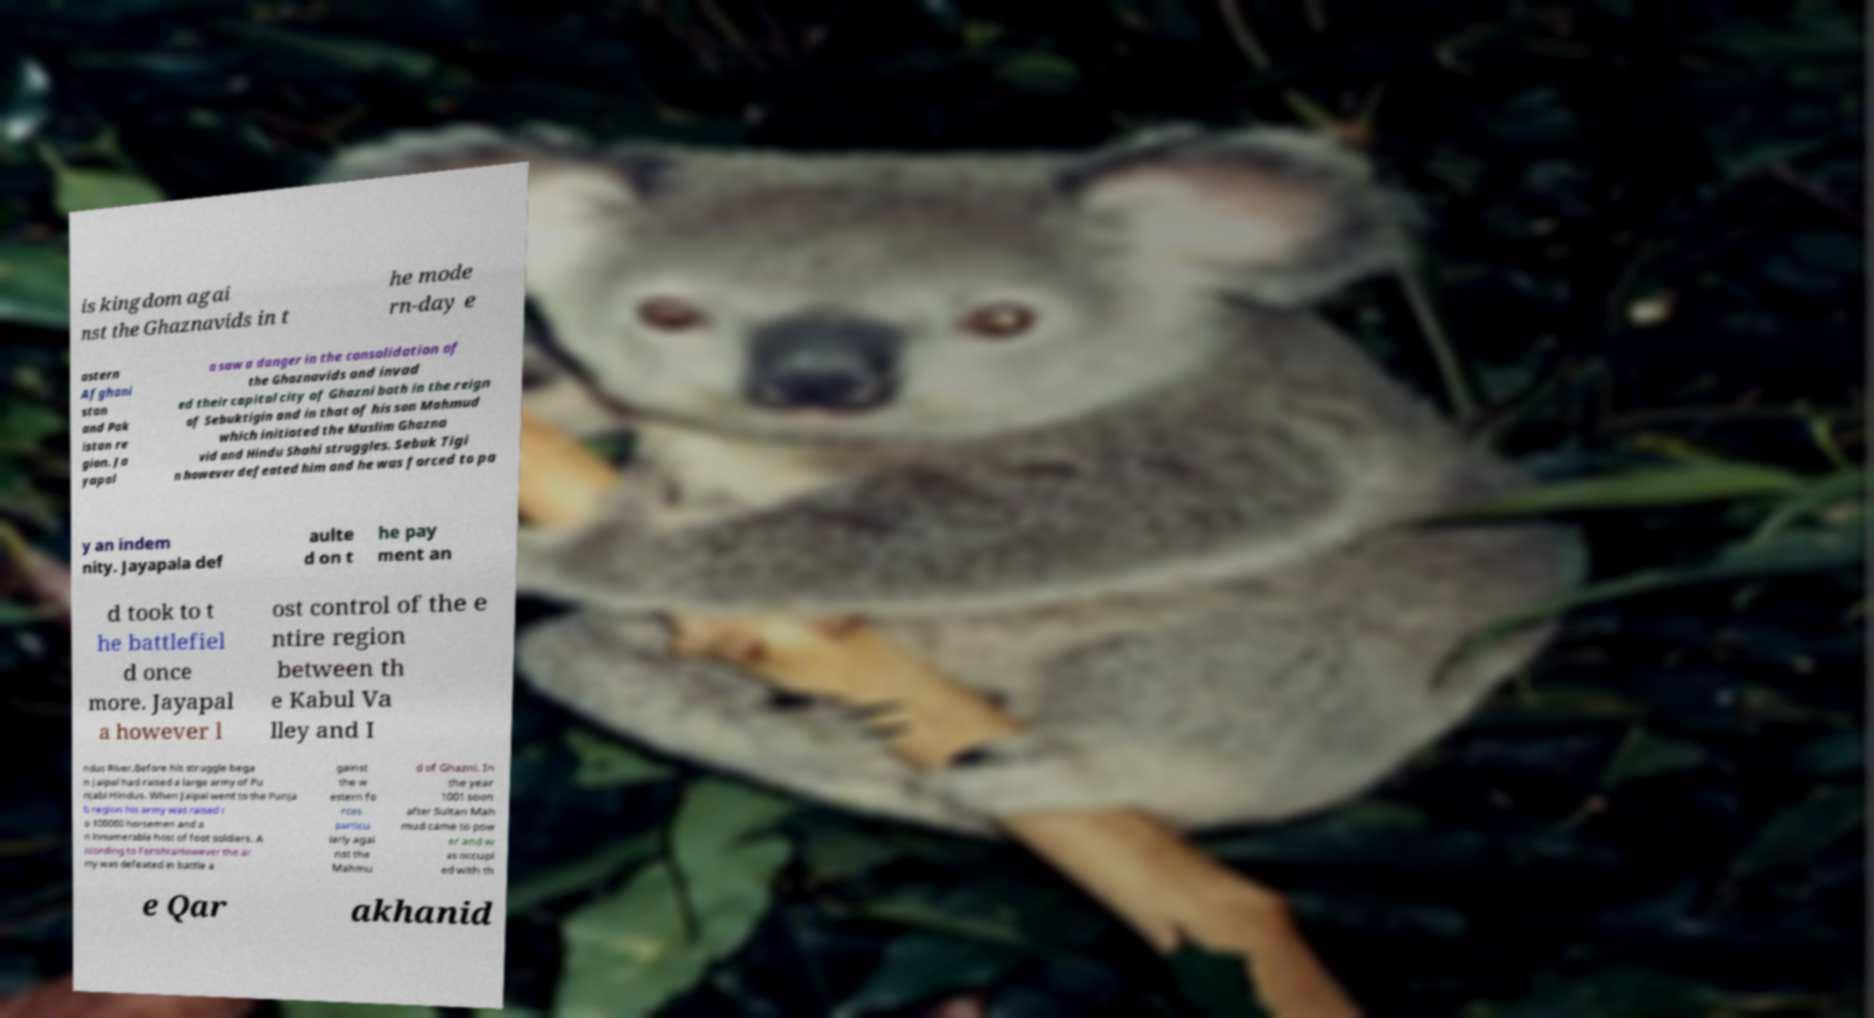I need the written content from this picture converted into text. Can you do that? is kingdom agai nst the Ghaznavids in t he mode rn-day e astern Afghani stan and Pak istan re gion. Ja yapal a saw a danger in the consolidation of the Ghaznavids and invad ed their capital city of Ghazni both in the reign of Sebuktigin and in that of his son Mahmud which initiated the Muslim Ghazna vid and Hindu Shahi struggles. Sebuk Tigi n however defeated him and he was forced to pa y an indem nity. Jayapala def aulte d on t he pay ment an d took to t he battlefiel d once more. Jayapal a however l ost control of the e ntire region between th e Kabul Va lley and I ndus River.Before his struggle bega n Jaipal had raised a large army of Pu njabi Hindus. When Jaipal went to the Punja b region his army was raised t o 100000 horsemen and a n innumerable host of foot soldiers. A ccording to FerishtaHowever the ar my was defeated in battle a gainst the w estern fo rces particu larly agai nst the Mahmu d of Ghazni. In the year 1001 soon after Sultan Mah mud came to pow er and w as occupi ed with th e Qar akhanid 